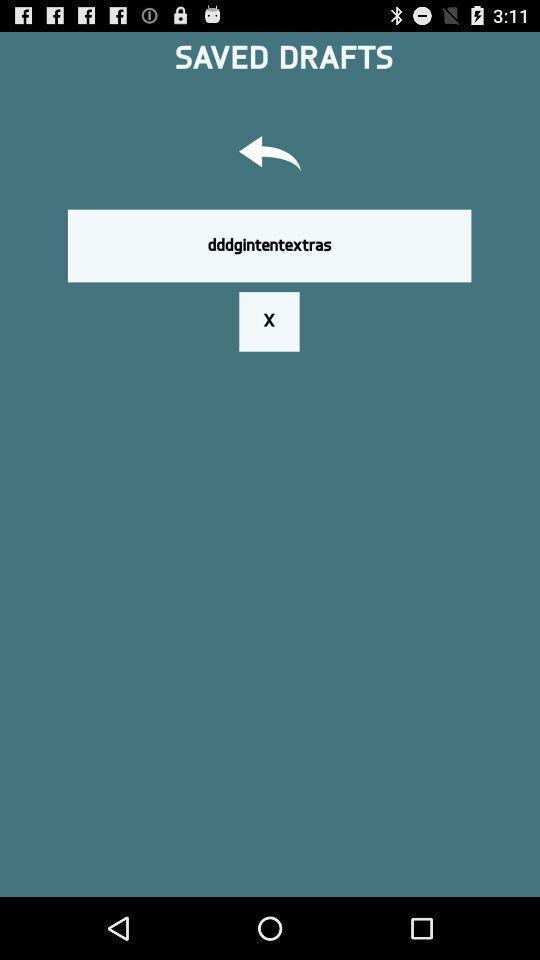Explain the elements present in this screenshot. Search bar in a drafts page. 